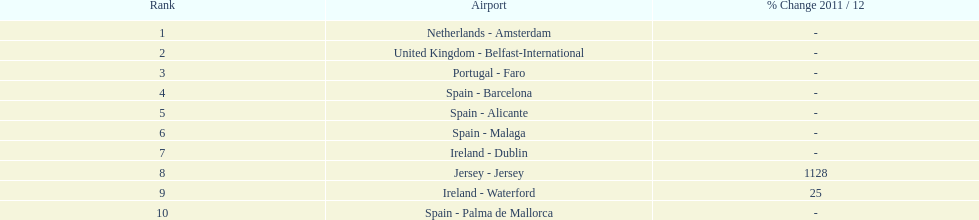Looking at the top 10 busiest routes to and from london southend airport what is the average number of passengers handled? 58,967.5. 